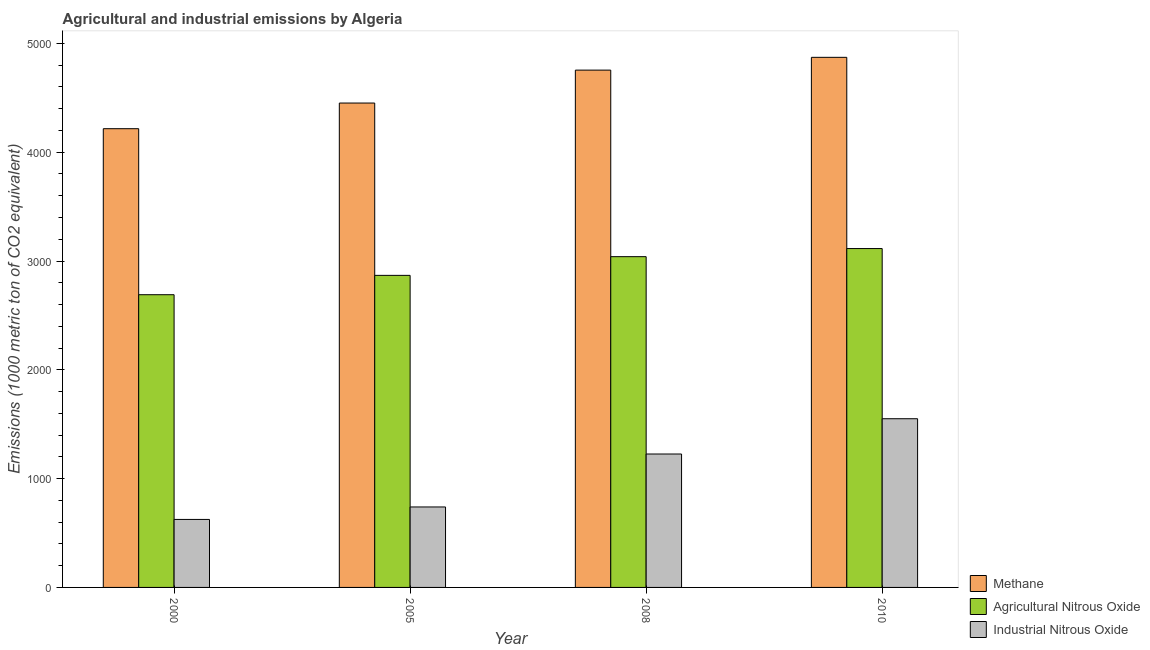How many different coloured bars are there?
Your answer should be very brief. 3. Are the number of bars per tick equal to the number of legend labels?
Keep it short and to the point. Yes. Are the number of bars on each tick of the X-axis equal?
Give a very brief answer. Yes. How many bars are there on the 2nd tick from the right?
Offer a terse response. 3. What is the amount of agricultural nitrous oxide emissions in 2005?
Your response must be concise. 2868.2. Across all years, what is the maximum amount of methane emissions?
Offer a very short reply. 4872.2. Across all years, what is the minimum amount of industrial nitrous oxide emissions?
Offer a very short reply. 625. In which year was the amount of industrial nitrous oxide emissions minimum?
Offer a terse response. 2000. What is the total amount of methane emissions in the graph?
Give a very brief answer. 1.83e+04. What is the difference between the amount of methane emissions in 2000 and that in 2010?
Keep it short and to the point. -655.9. What is the difference between the amount of methane emissions in 2000 and the amount of industrial nitrous oxide emissions in 2005?
Give a very brief answer. -235.8. What is the average amount of methane emissions per year?
Your response must be concise. 4573.83. In the year 2010, what is the difference between the amount of methane emissions and amount of industrial nitrous oxide emissions?
Your answer should be compact. 0. What is the ratio of the amount of agricultural nitrous oxide emissions in 2000 to that in 2010?
Give a very brief answer. 0.86. Is the difference between the amount of methane emissions in 2005 and 2010 greater than the difference between the amount of agricultural nitrous oxide emissions in 2005 and 2010?
Provide a succinct answer. No. What is the difference between the highest and the second highest amount of methane emissions?
Keep it short and to the point. 117.5. What is the difference between the highest and the lowest amount of methane emissions?
Keep it short and to the point. 655.9. Is the sum of the amount of methane emissions in 2008 and 2010 greater than the maximum amount of industrial nitrous oxide emissions across all years?
Ensure brevity in your answer.  Yes. What does the 3rd bar from the left in 2005 represents?
Your answer should be compact. Industrial Nitrous Oxide. What does the 3rd bar from the right in 2000 represents?
Provide a succinct answer. Methane. Is it the case that in every year, the sum of the amount of methane emissions and amount of agricultural nitrous oxide emissions is greater than the amount of industrial nitrous oxide emissions?
Make the answer very short. Yes. Are all the bars in the graph horizontal?
Keep it short and to the point. No. How many years are there in the graph?
Make the answer very short. 4. Are the values on the major ticks of Y-axis written in scientific E-notation?
Offer a very short reply. No. Does the graph contain grids?
Provide a short and direct response. No. How many legend labels are there?
Provide a short and direct response. 3. How are the legend labels stacked?
Provide a succinct answer. Vertical. What is the title of the graph?
Provide a short and direct response. Agricultural and industrial emissions by Algeria. Does "Male employers" appear as one of the legend labels in the graph?
Offer a terse response. No. What is the label or title of the X-axis?
Ensure brevity in your answer.  Year. What is the label or title of the Y-axis?
Provide a succinct answer. Emissions (1000 metric ton of CO2 equivalent). What is the Emissions (1000 metric ton of CO2 equivalent) in Methane in 2000?
Ensure brevity in your answer.  4216.3. What is the Emissions (1000 metric ton of CO2 equivalent) of Agricultural Nitrous Oxide in 2000?
Your answer should be compact. 2690.4. What is the Emissions (1000 metric ton of CO2 equivalent) in Industrial Nitrous Oxide in 2000?
Ensure brevity in your answer.  625. What is the Emissions (1000 metric ton of CO2 equivalent) in Methane in 2005?
Give a very brief answer. 4452.1. What is the Emissions (1000 metric ton of CO2 equivalent) in Agricultural Nitrous Oxide in 2005?
Your answer should be compact. 2868.2. What is the Emissions (1000 metric ton of CO2 equivalent) in Industrial Nitrous Oxide in 2005?
Offer a terse response. 739.6. What is the Emissions (1000 metric ton of CO2 equivalent) in Methane in 2008?
Offer a very short reply. 4754.7. What is the Emissions (1000 metric ton of CO2 equivalent) of Agricultural Nitrous Oxide in 2008?
Offer a terse response. 3040.1. What is the Emissions (1000 metric ton of CO2 equivalent) in Industrial Nitrous Oxide in 2008?
Ensure brevity in your answer.  1226.2. What is the Emissions (1000 metric ton of CO2 equivalent) in Methane in 2010?
Provide a short and direct response. 4872.2. What is the Emissions (1000 metric ton of CO2 equivalent) of Agricultural Nitrous Oxide in 2010?
Offer a very short reply. 3114.6. What is the Emissions (1000 metric ton of CO2 equivalent) in Industrial Nitrous Oxide in 2010?
Your answer should be compact. 1550.6. Across all years, what is the maximum Emissions (1000 metric ton of CO2 equivalent) in Methane?
Your answer should be very brief. 4872.2. Across all years, what is the maximum Emissions (1000 metric ton of CO2 equivalent) in Agricultural Nitrous Oxide?
Keep it short and to the point. 3114.6. Across all years, what is the maximum Emissions (1000 metric ton of CO2 equivalent) in Industrial Nitrous Oxide?
Make the answer very short. 1550.6. Across all years, what is the minimum Emissions (1000 metric ton of CO2 equivalent) in Methane?
Make the answer very short. 4216.3. Across all years, what is the minimum Emissions (1000 metric ton of CO2 equivalent) in Agricultural Nitrous Oxide?
Provide a short and direct response. 2690.4. Across all years, what is the minimum Emissions (1000 metric ton of CO2 equivalent) in Industrial Nitrous Oxide?
Provide a succinct answer. 625. What is the total Emissions (1000 metric ton of CO2 equivalent) of Methane in the graph?
Ensure brevity in your answer.  1.83e+04. What is the total Emissions (1000 metric ton of CO2 equivalent) of Agricultural Nitrous Oxide in the graph?
Offer a terse response. 1.17e+04. What is the total Emissions (1000 metric ton of CO2 equivalent) of Industrial Nitrous Oxide in the graph?
Your answer should be compact. 4141.4. What is the difference between the Emissions (1000 metric ton of CO2 equivalent) in Methane in 2000 and that in 2005?
Offer a terse response. -235.8. What is the difference between the Emissions (1000 metric ton of CO2 equivalent) of Agricultural Nitrous Oxide in 2000 and that in 2005?
Offer a terse response. -177.8. What is the difference between the Emissions (1000 metric ton of CO2 equivalent) in Industrial Nitrous Oxide in 2000 and that in 2005?
Make the answer very short. -114.6. What is the difference between the Emissions (1000 metric ton of CO2 equivalent) of Methane in 2000 and that in 2008?
Provide a short and direct response. -538.4. What is the difference between the Emissions (1000 metric ton of CO2 equivalent) in Agricultural Nitrous Oxide in 2000 and that in 2008?
Offer a terse response. -349.7. What is the difference between the Emissions (1000 metric ton of CO2 equivalent) in Industrial Nitrous Oxide in 2000 and that in 2008?
Provide a succinct answer. -601.2. What is the difference between the Emissions (1000 metric ton of CO2 equivalent) of Methane in 2000 and that in 2010?
Keep it short and to the point. -655.9. What is the difference between the Emissions (1000 metric ton of CO2 equivalent) in Agricultural Nitrous Oxide in 2000 and that in 2010?
Keep it short and to the point. -424.2. What is the difference between the Emissions (1000 metric ton of CO2 equivalent) in Industrial Nitrous Oxide in 2000 and that in 2010?
Your answer should be very brief. -925.6. What is the difference between the Emissions (1000 metric ton of CO2 equivalent) of Methane in 2005 and that in 2008?
Your answer should be compact. -302.6. What is the difference between the Emissions (1000 metric ton of CO2 equivalent) in Agricultural Nitrous Oxide in 2005 and that in 2008?
Offer a terse response. -171.9. What is the difference between the Emissions (1000 metric ton of CO2 equivalent) of Industrial Nitrous Oxide in 2005 and that in 2008?
Keep it short and to the point. -486.6. What is the difference between the Emissions (1000 metric ton of CO2 equivalent) in Methane in 2005 and that in 2010?
Your answer should be compact. -420.1. What is the difference between the Emissions (1000 metric ton of CO2 equivalent) of Agricultural Nitrous Oxide in 2005 and that in 2010?
Offer a terse response. -246.4. What is the difference between the Emissions (1000 metric ton of CO2 equivalent) in Industrial Nitrous Oxide in 2005 and that in 2010?
Ensure brevity in your answer.  -811. What is the difference between the Emissions (1000 metric ton of CO2 equivalent) of Methane in 2008 and that in 2010?
Your answer should be very brief. -117.5. What is the difference between the Emissions (1000 metric ton of CO2 equivalent) in Agricultural Nitrous Oxide in 2008 and that in 2010?
Make the answer very short. -74.5. What is the difference between the Emissions (1000 metric ton of CO2 equivalent) of Industrial Nitrous Oxide in 2008 and that in 2010?
Keep it short and to the point. -324.4. What is the difference between the Emissions (1000 metric ton of CO2 equivalent) in Methane in 2000 and the Emissions (1000 metric ton of CO2 equivalent) in Agricultural Nitrous Oxide in 2005?
Provide a short and direct response. 1348.1. What is the difference between the Emissions (1000 metric ton of CO2 equivalent) in Methane in 2000 and the Emissions (1000 metric ton of CO2 equivalent) in Industrial Nitrous Oxide in 2005?
Provide a succinct answer. 3476.7. What is the difference between the Emissions (1000 metric ton of CO2 equivalent) of Agricultural Nitrous Oxide in 2000 and the Emissions (1000 metric ton of CO2 equivalent) of Industrial Nitrous Oxide in 2005?
Offer a very short reply. 1950.8. What is the difference between the Emissions (1000 metric ton of CO2 equivalent) of Methane in 2000 and the Emissions (1000 metric ton of CO2 equivalent) of Agricultural Nitrous Oxide in 2008?
Give a very brief answer. 1176.2. What is the difference between the Emissions (1000 metric ton of CO2 equivalent) in Methane in 2000 and the Emissions (1000 metric ton of CO2 equivalent) in Industrial Nitrous Oxide in 2008?
Your response must be concise. 2990.1. What is the difference between the Emissions (1000 metric ton of CO2 equivalent) of Agricultural Nitrous Oxide in 2000 and the Emissions (1000 metric ton of CO2 equivalent) of Industrial Nitrous Oxide in 2008?
Provide a succinct answer. 1464.2. What is the difference between the Emissions (1000 metric ton of CO2 equivalent) in Methane in 2000 and the Emissions (1000 metric ton of CO2 equivalent) in Agricultural Nitrous Oxide in 2010?
Offer a very short reply. 1101.7. What is the difference between the Emissions (1000 metric ton of CO2 equivalent) in Methane in 2000 and the Emissions (1000 metric ton of CO2 equivalent) in Industrial Nitrous Oxide in 2010?
Keep it short and to the point. 2665.7. What is the difference between the Emissions (1000 metric ton of CO2 equivalent) of Agricultural Nitrous Oxide in 2000 and the Emissions (1000 metric ton of CO2 equivalent) of Industrial Nitrous Oxide in 2010?
Give a very brief answer. 1139.8. What is the difference between the Emissions (1000 metric ton of CO2 equivalent) in Methane in 2005 and the Emissions (1000 metric ton of CO2 equivalent) in Agricultural Nitrous Oxide in 2008?
Your answer should be very brief. 1412. What is the difference between the Emissions (1000 metric ton of CO2 equivalent) in Methane in 2005 and the Emissions (1000 metric ton of CO2 equivalent) in Industrial Nitrous Oxide in 2008?
Your answer should be very brief. 3225.9. What is the difference between the Emissions (1000 metric ton of CO2 equivalent) in Agricultural Nitrous Oxide in 2005 and the Emissions (1000 metric ton of CO2 equivalent) in Industrial Nitrous Oxide in 2008?
Give a very brief answer. 1642. What is the difference between the Emissions (1000 metric ton of CO2 equivalent) in Methane in 2005 and the Emissions (1000 metric ton of CO2 equivalent) in Agricultural Nitrous Oxide in 2010?
Provide a succinct answer. 1337.5. What is the difference between the Emissions (1000 metric ton of CO2 equivalent) of Methane in 2005 and the Emissions (1000 metric ton of CO2 equivalent) of Industrial Nitrous Oxide in 2010?
Keep it short and to the point. 2901.5. What is the difference between the Emissions (1000 metric ton of CO2 equivalent) of Agricultural Nitrous Oxide in 2005 and the Emissions (1000 metric ton of CO2 equivalent) of Industrial Nitrous Oxide in 2010?
Offer a very short reply. 1317.6. What is the difference between the Emissions (1000 metric ton of CO2 equivalent) in Methane in 2008 and the Emissions (1000 metric ton of CO2 equivalent) in Agricultural Nitrous Oxide in 2010?
Your answer should be very brief. 1640.1. What is the difference between the Emissions (1000 metric ton of CO2 equivalent) of Methane in 2008 and the Emissions (1000 metric ton of CO2 equivalent) of Industrial Nitrous Oxide in 2010?
Your answer should be compact. 3204.1. What is the difference between the Emissions (1000 metric ton of CO2 equivalent) in Agricultural Nitrous Oxide in 2008 and the Emissions (1000 metric ton of CO2 equivalent) in Industrial Nitrous Oxide in 2010?
Your answer should be very brief. 1489.5. What is the average Emissions (1000 metric ton of CO2 equivalent) of Methane per year?
Offer a very short reply. 4573.82. What is the average Emissions (1000 metric ton of CO2 equivalent) of Agricultural Nitrous Oxide per year?
Give a very brief answer. 2928.32. What is the average Emissions (1000 metric ton of CO2 equivalent) of Industrial Nitrous Oxide per year?
Keep it short and to the point. 1035.35. In the year 2000, what is the difference between the Emissions (1000 metric ton of CO2 equivalent) in Methane and Emissions (1000 metric ton of CO2 equivalent) in Agricultural Nitrous Oxide?
Ensure brevity in your answer.  1525.9. In the year 2000, what is the difference between the Emissions (1000 metric ton of CO2 equivalent) of Methane and Emissions (1000 metric ton of CO2 equivalent) of Industrial Nitrous Oxide?
Offer a terse response. 3591.3. In the year 2000, what is the difference between the Emissions (1000 metric ton of CO2 equivalent) in Agricultural Nitrous Oxide and Emissions (1000 metric ton of CO2 equivalent) in Industrial Nitrous Oxide?
Offer a terse response. 2065.4. In the year 2005, what is the difference between the Emissions (1000 metric ton of CO2 equivalent) in Methane and Emissions (1000 metric ton of CO2 equivalent) in Agricultural Nitrous Oxide?
Give a very brief answer. 1583.9. In the year 2005, what is the difference between the Emissions (1000 metric ton of CO2 equivalent) in Methane and Emissions (1000 metric ton of CO2 equivalent) in Industrial Nitrous Oxide?
Keep it short and to the point. 3712.5. In the year 2005, what is the difference between the Emissions (1000 metric ton of CO2 equivalent) of Agricultural Nitrous Oxide and Emissions (1000 metric ton of CO2 equivalent) of Industrial Nitrous Oxide?
Your answer should be compact. 2128.6. In the year 2008, what is the difference between the Emissions (1000 metric ton of CO2 equivalent) of Methane and Emissions (1000 metric ton of CO2 equivalent) of Agricultural Nitrous Oxide?
Give a very brief answer. 1714.6. In the year 2008, what is the difference between the Emissions (1000 metric ton of CO2 equivalent) of Methane and Emissions (1000 metric ton of CO2 equivalent) of Industrial Nitrous Oxide?
Your answer should be compact. 3528.5. In the year 2008, what is the difference between the Emissions (1000 metric ton of CO2 equivalent) of Agricultural Nitrous Oxide and Emissions (1000 metric ton of CO2 equivalent) of Industrial Nitrous Oxide?
Provide a succinct answer. 1813.9. In the year 2010, what is the difference between the Emissions (1000 metric ton of CO2 equivalent) in Methane and Emissions (1000 metric ton of CO2 equivalent) in Agricultural Nitrous Oxide?
Your answer should be compact. 1757.6. In the year 2010, what is the difference between the Emissions (1000 metric ton of CO2 equivalent) in Methane and Emissions (1000 metric ton of CO2 equivalent) in Industrial Nitrous Oxide?
Offer a very short reply. 3321.6. In the year 2010, what is the difference between the Emissions (1000 metric ton of CO2 equivalent) in Agricultural Nitrous Oxide and Emissions (1000 metric ton of CO2 equivalent) in Industrial Nitrous Oxide?
Offer a very short reply. 1564. What is the ratio of the Emissions (1000 metric ton of CO2 equivalent) of Methane in 2000 to that in 2005?
Your response must be concise. 0.95. What is the ratio of the Emissions (1000 metric ton of CO2 equivalent) of Agricultural Nitrous Oxide in 2000 to that in 2005?
Your response must be concise. 0.94. What is the ratio of the Emissions (1000 metric ton of CO2 equivalent) in Industrial Nitrous Oxide in 2000 to that in 2005?
Make the answer very short. 0.85. What is the ratio of the Emissions (1000 metric ton of CO2 equivalent) of Methane in 2000 to that in 2008?
Your answer should be very brief. 0.89. What is the ratio of the Emissions (1000 metric ton of CO2 equivalent) in Agricultural Nitrous Oxide in 2000 to that in 2008?
Your answer should be compact. 0.89. What is the ratio of the Emissions (1000 metric ton of CO2 equivalent) in Industrial Nitrous Oxide in 2000 to that in 2008?
Provide a succinct answer. 0.51. What is the ratio of the Emissions (1000 metric ton of CO2 equivalent) of Methane in 2000 to that in 2010?
Keep it short and to the point. 0.87. What is the ratio of the Emissions (1000 metric ton of CO2 equivalent) of Agricultural Nitrous Oxide in 2000 to that in 2010?
Your answer should be very brief. 0.86. What is the ratio of the Emissions (1000 metric ton of CO2 equivalent) of Industrial Nitrous Oxide in 2000 to that in 2010?
Keep it short and to the point. 0.4. What is the ratio of the Emissions (1000 metric ton of CO2 equivalent) in Methane in 2005 to that in 2008?
Make the answer very short. 0.94. What is the ratio of the Emissions (1000 metric ton of CO2 equivalent) of Agricultural Nitrous Oxide in 2005 to that in 2008?
Your response must be concise. 0.94. What is the ratio of the Emissions (1000 metric ton of CO2 equivalent) in Industrial Nitrous Oxide in 2005 to that in 2008?
Your answer should be compact. 0.6. What is the ratio of the Emissions (1000 metric ton of CO2 equivalent) of Methane in 2005 to that in 2010?
Provide a succinct answer. 0.91. What is the ratio of the Emissions (1000 metric ton of CO2 equivalent) in Agricultural Nitrous Oxide in 2005 to that in 2010?
Offer a terse response. 0.92. What is the ratio of the Emissions (1000 metric ton of CO2 equivalent) of Industrial Nitrous Oxide in 2005 to that in 2010?
Offer a terse response. 0.48. What is the ratio of the Emissions (1000 metric ton of CO2 equivalent) in Methane in 2008 to that in 2010?
Offer a very short reply. 0.98. What is the ratio of the Emissions (1000 metric ton of CO2 equivalent) in Agricultural Nitrous Oxide in 2008 to that in 2010?
Your answer should be very brief. 0.98. What is the ratio of the Emissions (1000 metric ton of CO2 equivalent) in Industrial Nitrous Oxide in 2008 to that in 2010?
Provide a succinct answer. 0.79. What is the difference between the highest and the second highest Emissions (1000 metric ton of CO2 equivalent) in Methane?
Provide a succinct answer. 117.5. What is the difference between the highest and the second highest Emissions (1000 metric ton of CO2 equivalent) in Agricultural Nitrous Oxide?
Keep it short and to the point. 74.5. What is the difference between the highest and the second highest Emissions (1000 metric ton of CO2 equivalent) of Industrial Nitrous Oxide?
Keep it short and to the point. 324.4. What is the difference between the highest and the lowest Emissions (1000 metric ton of CO2 equivalent) in Methane?
Your answer should be compact. 655.9. What is the difference between the highest and the lowest Emissions (1000 metric ton of CO2 equivalent) of Agricultural Nitrous Oxide?
Provide a succinct answer. 424.2. What is the difference between the highest and the lowest Emissions (1000 metric ton of CO2 equivalent) in Industrial Nitrous Oxide?
Your answer should be compact. 925.6. 